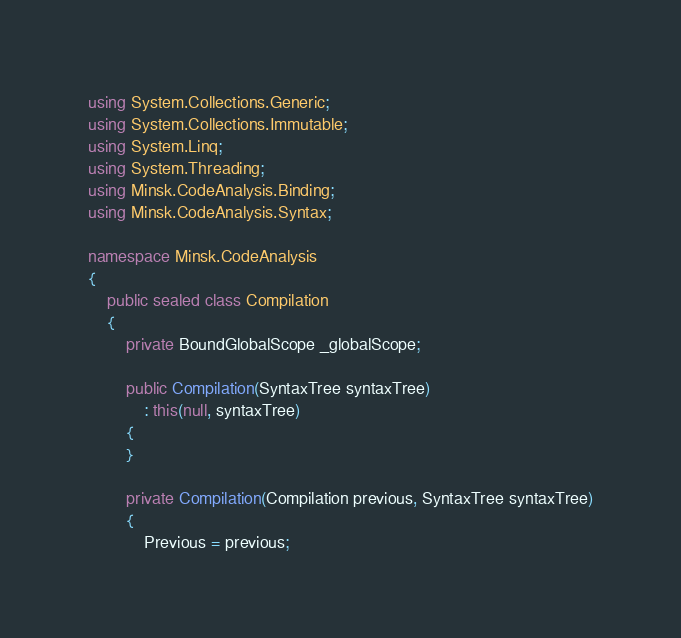Convert code to text. <code><loc_0><loc_0><loc_500><loc_500><_C#_>using System.Collections.Generic;
using System.Collections.Immutable;
using System.Linq;
using System.Threading;
using Minsk.CodeAnalysis.Binding;
using Minsk.CodeAnalysis.Syntax;

namespace Minsk.CodeAnalysis
{
    public sealed class Compilation
    {
        private BoundGlobalScope _globalScope;

        public Compilation(SyntaxTree syntaxTree)
            : this(null, syntaxTree)
        {
        }

        private Compilation(Compilation previous, SyntaxTree syntaxTree)
        {
            Previous = previous;</code> 